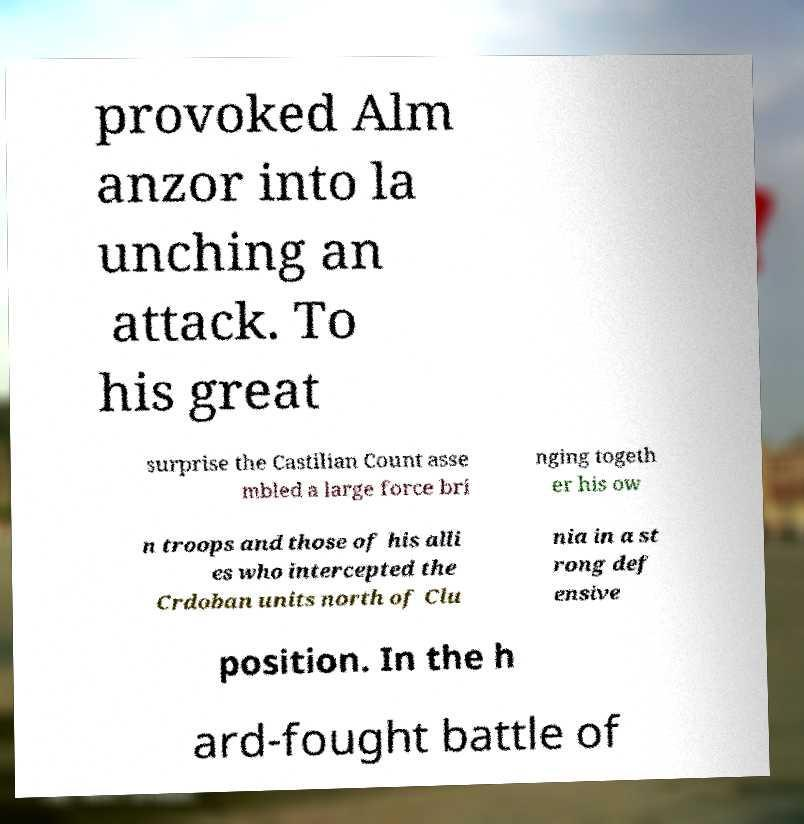Could you assist in decoding the text presented in this image and type it out clearly? provoked Alm anzor into la unching an attack. To his great surprise the Castilian Count asse mbled a large force bri nging togeth er his ow n troops and those of his alli es who intercepted the Crdoban units north of Clu nia in a st rong def ensive position. In the h ard-fought battle of 